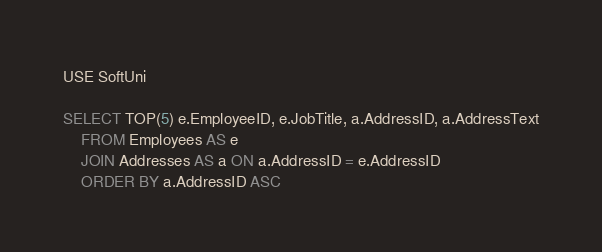Convert code to text. <code><loc_0><loc_0><loc_500><loc_500><_SQL_>USE SoftUni

SELECT TOP(5) e.EmployeeID, e.JobTitle, a.AddressID, a.AddressText
	FROM Employees AS e
	JOIN Addresses AS a ON a.AddressID = e.AddressID 
	ORDER BY a.AddressID ASC</code> 